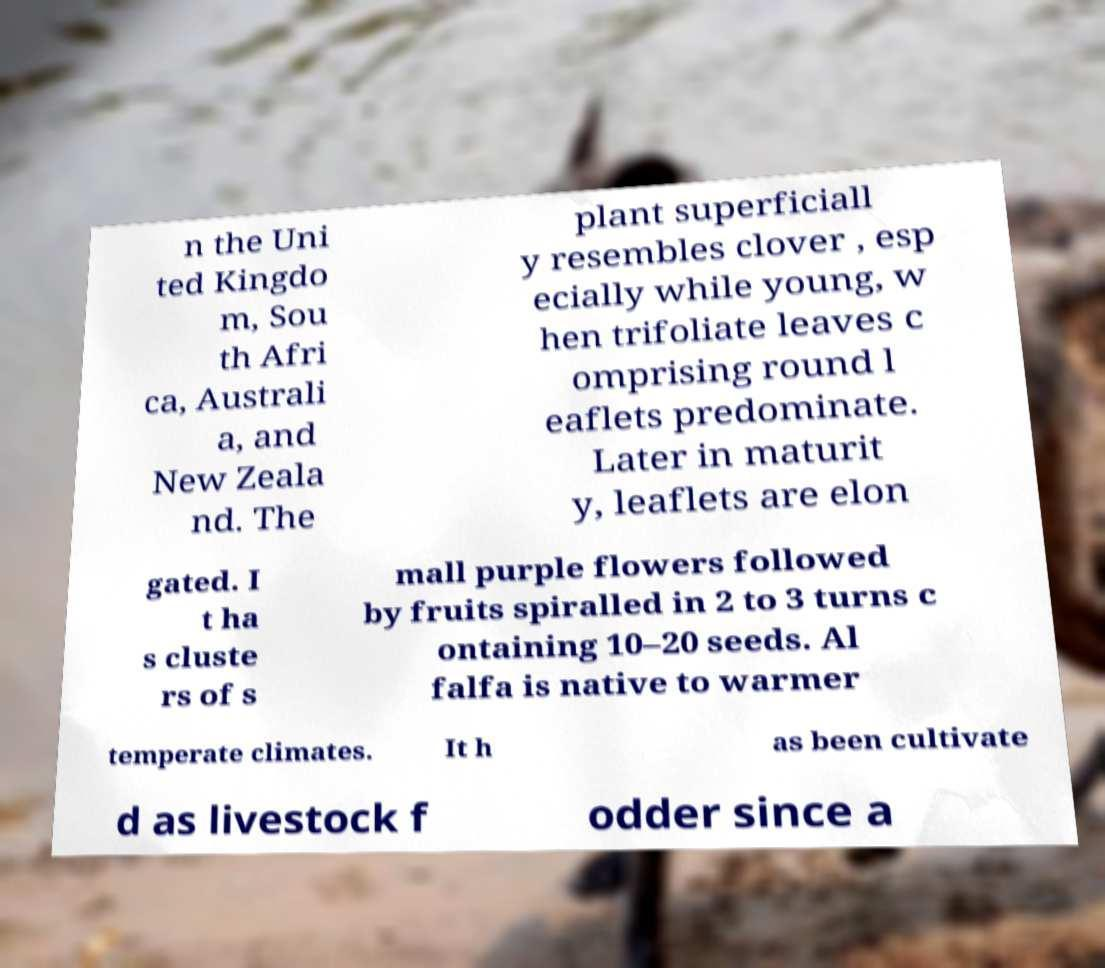Please read and relay the text visible in this image. What does it say? n the Uni ted Kingdo m, Sou th Afri ca, Australi a, and New Zeala nd. The plant superficiall y resembles clover , esp ecially while young, w hen trifoliate leaves c omprising round l eaflets predominate. Later in maturit y, leaflets are elon gated. I t ha s cluste rs of s mall purple flowers followed by fruits spiralled in 2 to 3 turns c ontaining 10–20 seeds. Al falfa is native to warmer temperate climates. It h as been cultivate d as livestock f odder since a 